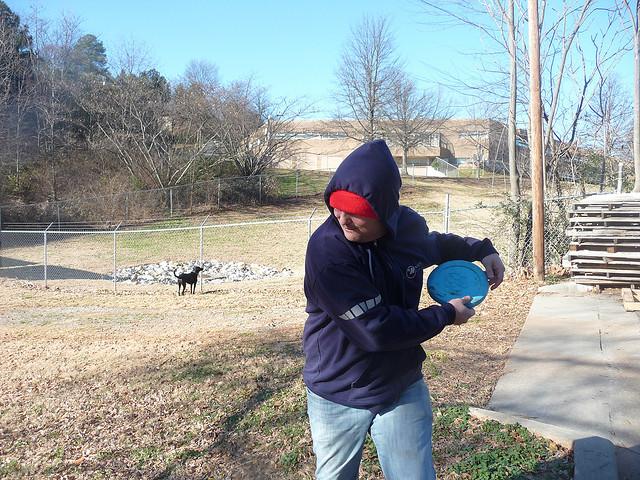What color is the god in the background?
Be succinct. Black. What material is the man's pants?
Short answer required. Denim. What is the person holding?
Concise answer only. Frisbee. 